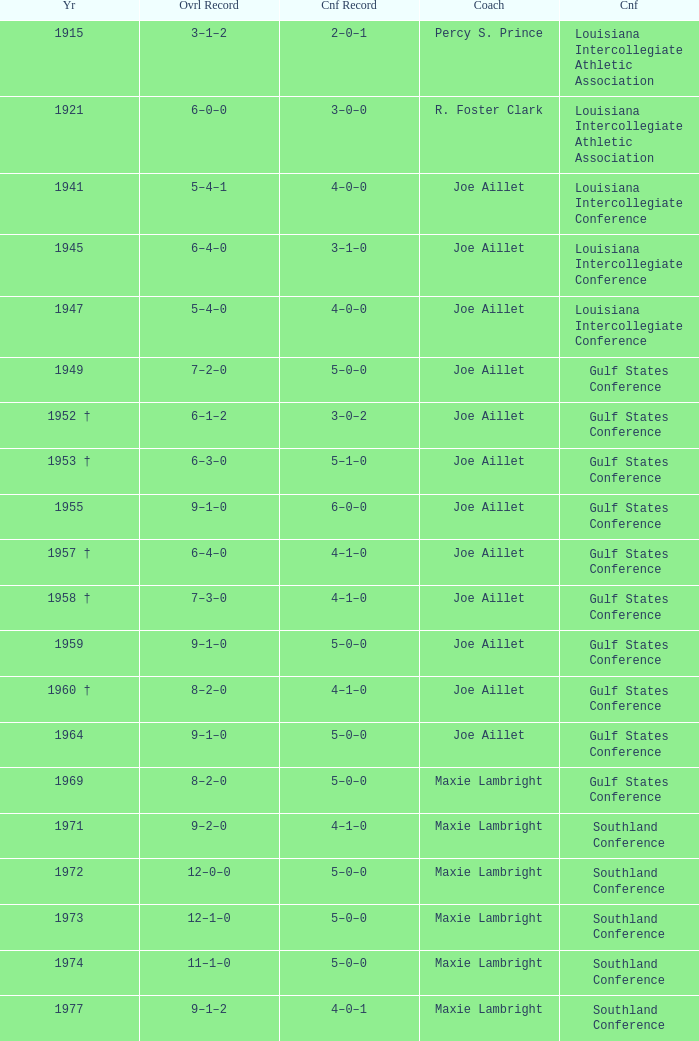What is the symposium record for the year of 1971? 4–1–0. 